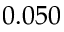Convert formula to latex. <formula><loc_0><loc_0><loc_500><loc_500>0 . 0 5 0</formula> 